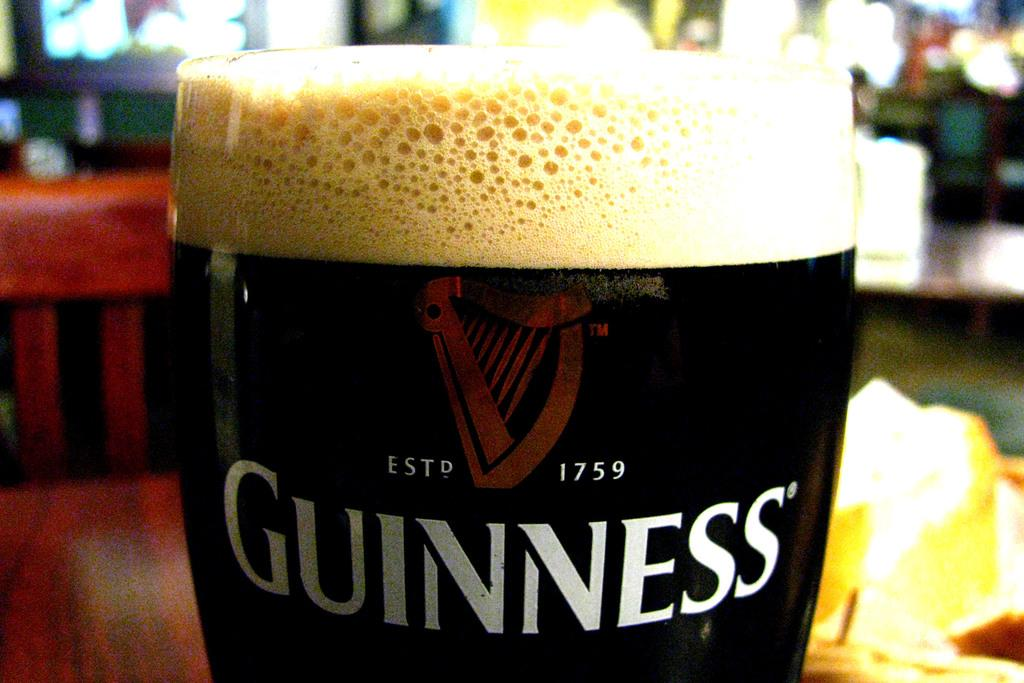<image>
Render a clear and concise summary of the photo. a close-up to a full glass of dark guiness 